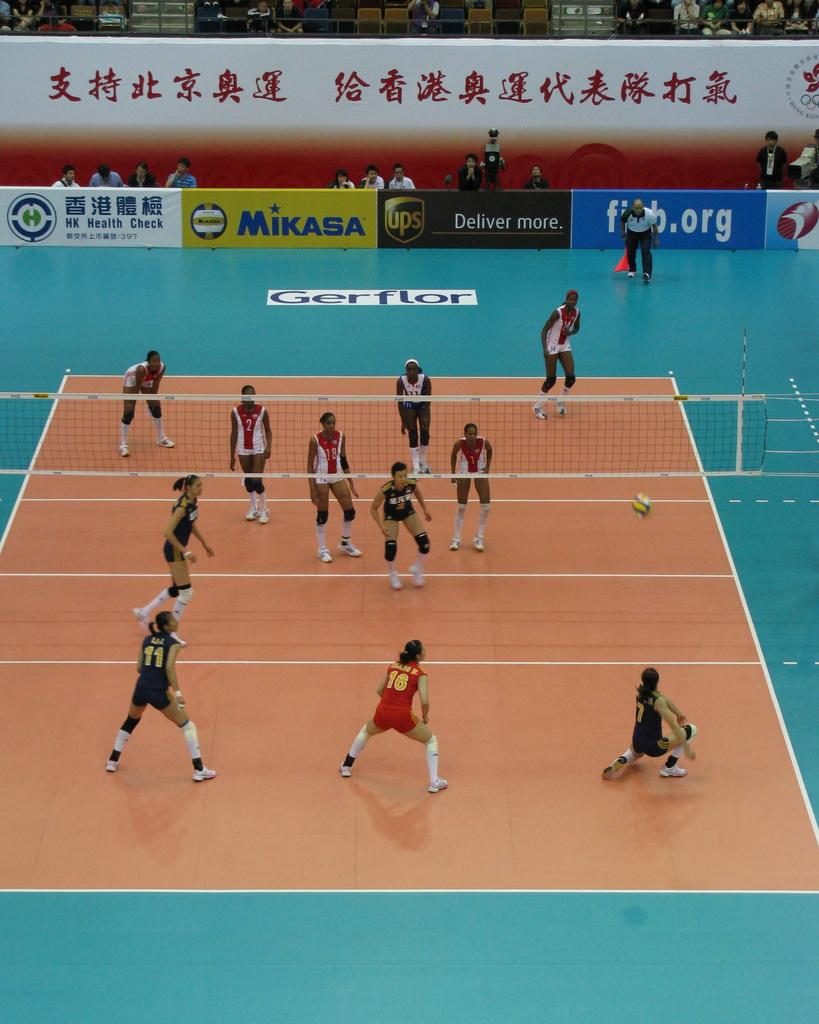<image>
Summarize the visual content of the image. Two groups of women playing volleyball on a court with a Mikasa advertisement in the background. 